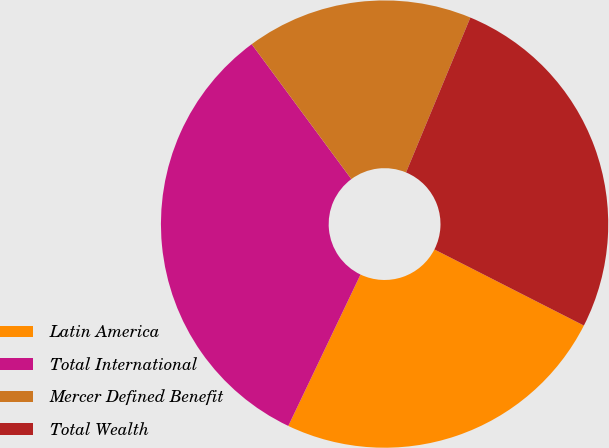Convert chart to OTSL. <chart><loc_0><loc_0><loc_500><loc_500><pie_chart><fcel>Latin America<fcel>Total International<fcel>Mercer Defined Benefit<fcel>Total Wealth<nl><fcel>24.59%<fcel>32.79%<fcel>16.39%<fcel>26.23%<nl></chart> 